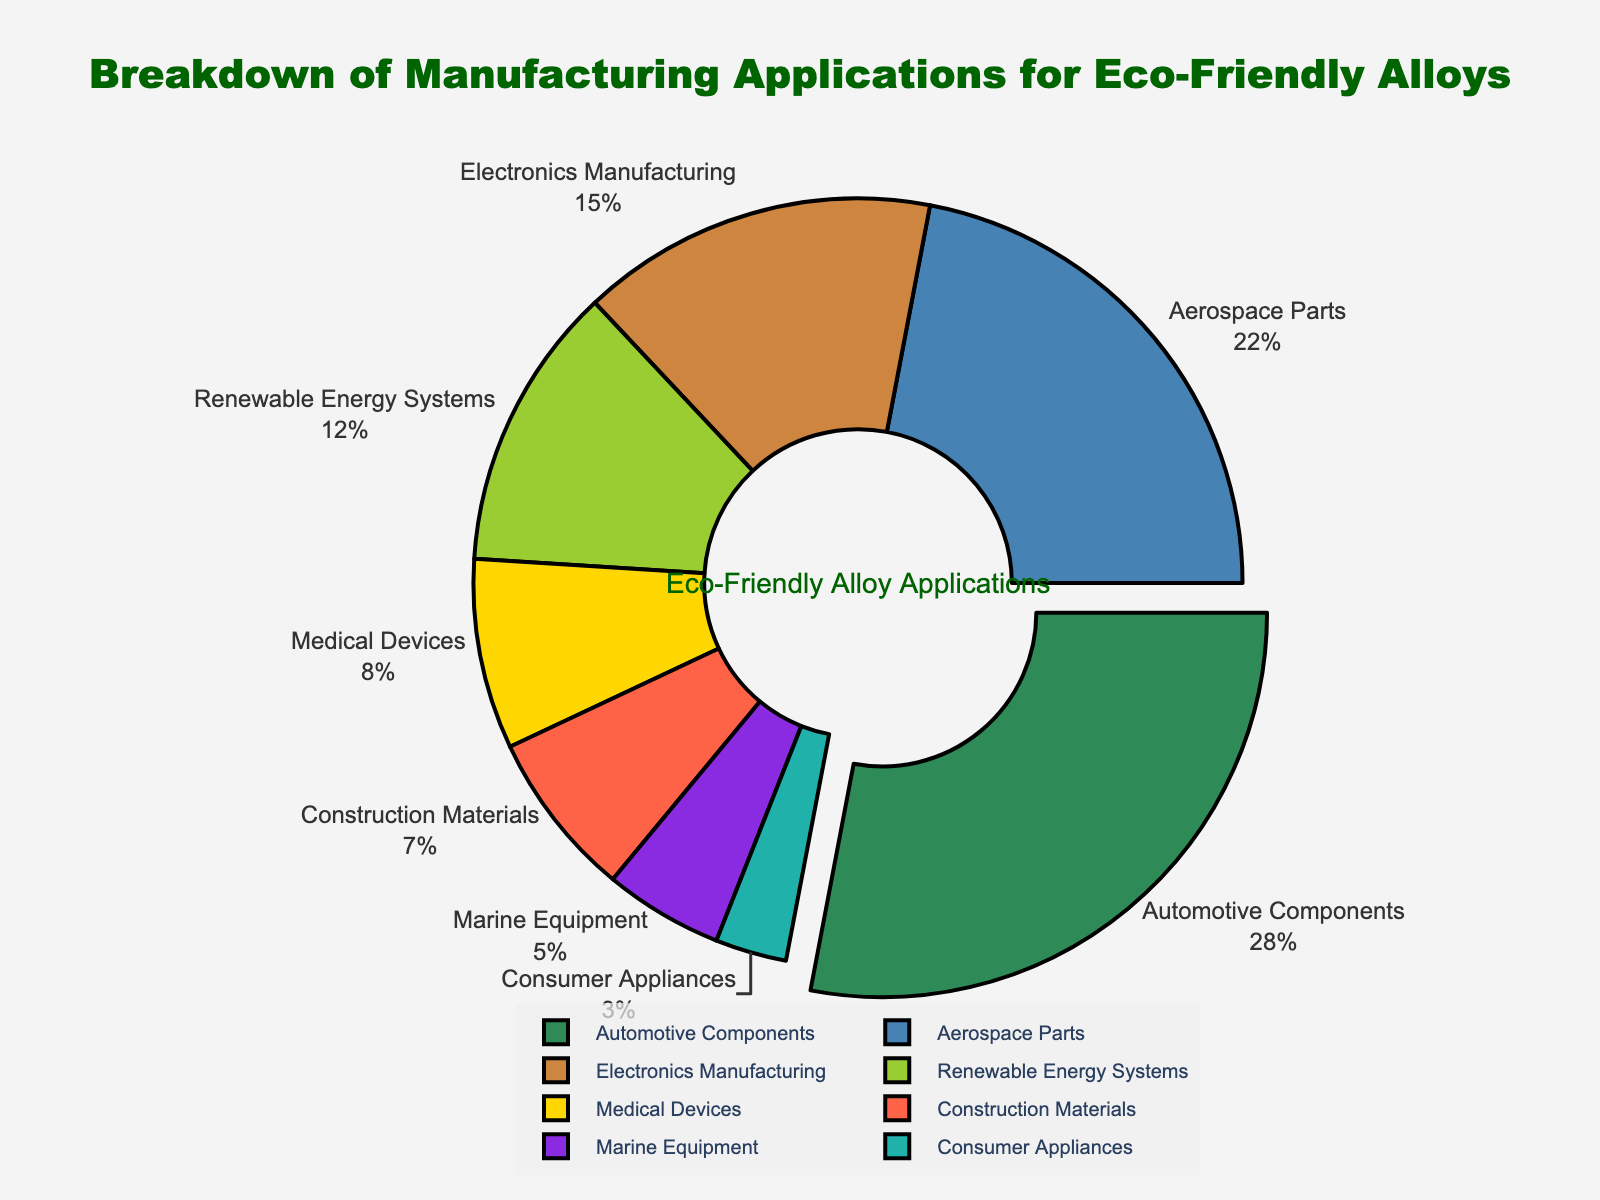Which manufacturing application has the highest percentage? The pie chart shows that the automotive components segment is pulled out from the rest, indicating it has the highest percentage.
Answer: Automotive Components What is the combined percentage for electronics manufacturing and medical devices? The pie chart lists electronics manufacturing at 15% and medical devices at 8%. The combined percentage is 15% + 8% = 23%.
Answer: 23% Which application has a higher percentage, aerospace parts or renewable energy systems? According to the pie chart, aerospace parts have a percentage of 22%, whereas renewable energy systems have 12%. Therefore, aerospace parts have a higher percentage.
Answer: Aerospace Parts Which manufacturing application occupies the smallest portion of the pie chart? The pie chart indicates the smallest portion by showing the consumer appliances segment with the smallest slice, which is 3%.
Answer: Consumer Appliances What is the difference in percentage between automotive components and marine equipment? The pie chart shows automotive components at 28% and marine equipment at 5%. The difference is 28% - 5% = 23%.
Answer: 23% What two applications together account for more than half of the pie chart? Automotive components (28%) and aerospace parts (22%) together account for 50%, which is more than half of the total percentage.
Answer: Automotive Components and Aerospace Parts Is the percentage for renewable energy systems more or less than the percentage for medical devices and construction materials combined? The pie chart shows renewable energy systems at 12%; medical devices and construction materials together are 8% + 7% = 15%. Therefore, renewable energy systems are less.
Answer: Less Which color represents the slice for marine equipment? By observing the colors in the pie chart and their corresponding segments, the marine equipment slice is shown in turquoise.
Answer: Turquoise What is the average percentage of the consumer appliances, medical devices, and construction materials segments? The pie chart provides the percentages as consumer appliances (3%), medical devices (8%), and construction materials (7%). The average percentage is (3% + 8% + 7%) / 3 = 18% / 3 = 6%.
Answer: 6% How many applications have a percentage greater than 20%? Inspecting the pie chart, we see that automotive components (28%) and aerospace parts (22%) are the only applications with percentages greater than 20%.
Answer: 2 